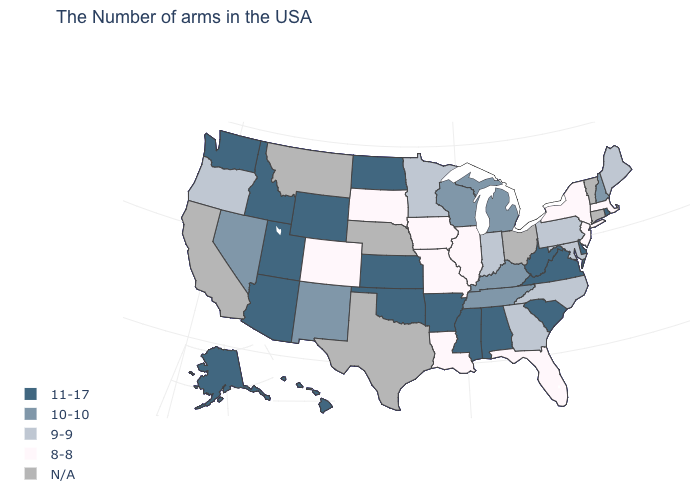Name the states that have a value in the range 11-17?
Quick response, please. Rhode Island, Delaware, Virginia, South Carolina, West Virginia, Alabama, Mississippi, Arkansas, Kansas, Oklahoma, North Dakota, Wyoming, Utah, Arizona, Idaho, Washington, Alaska, Hawaii. What is the value of Maine?
Concise answer only. 9-9. What is the value of Arizona?
Quick response, please. 11-17. Which states have the highest value in the USA?
Answer briefly. Rhode Island, Delaware, Virginia, South Carolina, West Virginia, Alabama, Mississippi, Arkansas, Kansas, Oklahoma, North Dakota, Wyoming, Utah, Arizona, Idaho, Washington, Alaska, Hawaii. Name the states that have a value in the range N/A?
Answer briefly. Vermont, Connecticut, Ohio, Nebraska, Texas, Montana, California. What is the highest value in the South ?
Concise answer only. 11-17. Name the states that have a value in the range 8-8?
Answer briefly. Massachusetts, New York, New Jersey, Florida, Illinois, Louisiana, Missouri, Iowa, South Dakota, Colorado. What is the value of West Virginia?
Short answer required. 11-17. Name the states that have a value in the range 10-10?
Write a very short answer. New Hampshire, Michigan, Kentucky, Tennessee, Wisconsin, New Mexico, Nevada. Does New Mexico have the highest value in the USA?
Be succinct. No. What is the lowest value in the South?
Be succinct. 8-8. What is the value of Missouri?
Quick response, please. 8-8. Is the legend a continuous bar?
Keep it brief. No. Name the states that have a value in the range N/A?
Write a very short answer. Vermont, Connecticut, Ohio, Nebraska, Texas, Montana, California. Which states hav the highest value in the West?
Keep it brief. Wyoming, Utah, Arizona, Idaho, Washington, Alaska, Hawaii. 